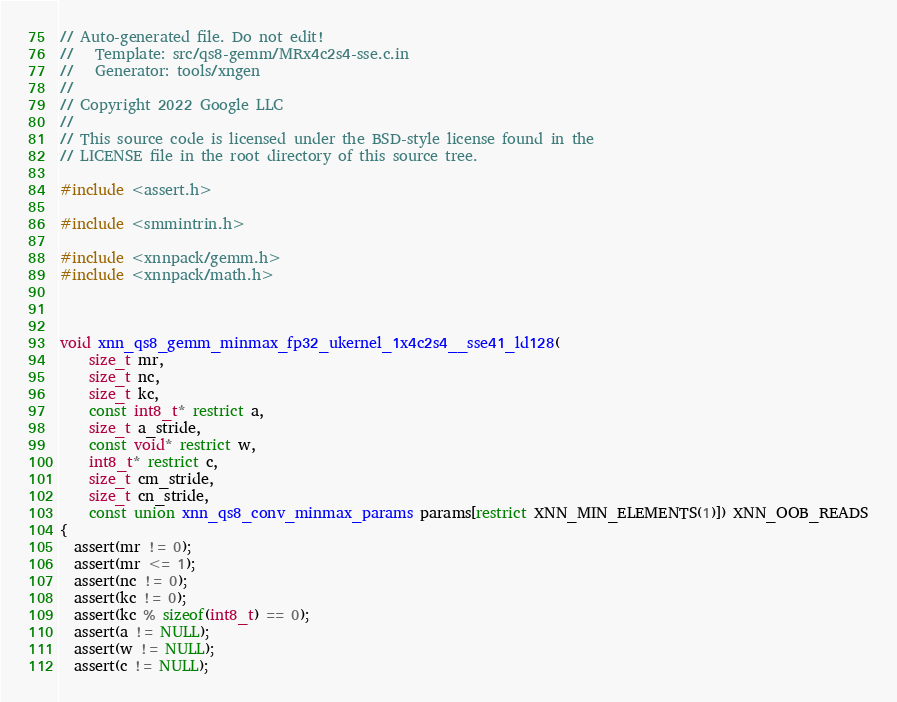Convert code to text. <code><loc_0><loc_0><loc_500><loc_500><_C_>// Auto-generated file. Do not edit!
//   Template: src/qs8-gemm/MRx4c2s4-sse.c.in
//   Generator: tools/xngen
//
// Copyright 2022 Google LLC
//
// This source code is licensed under the BSD-style license found in the
// LICENSE file in the root directory of this source tree.

#include <assert.h>

#include <smmintrin.h>

#include <xnnpack/gemm.h>
#include <xnnpack/math.h>



void xnn_qs8_gemm_minmax_fp32_ukernel_1x4c2s4__sse41_ld128(
    size_t mr,
    size_t nc,
    size_t kc,
    const int8_t* restrict a,
    size_t a_stride,
    const void* restrict w,
    int8_t* restrict c,
    size_t cm_stride,
    size_t cn_stride,
    const union xnn_qs8_conv_minmax_params params[restrict XNN_MIN_ELEMENTS(1)]) XNN_OOB_READS
{
  assert(mr != 0);
  assert(mr <= 1);
  assert(nc != 0);
  assert(kc != 0);
  assert(kc % sizeof(int8_t) == 0);
  assert(a != NULL);
  assert(w != NULL);
  assert(c != NULL);
</code> 